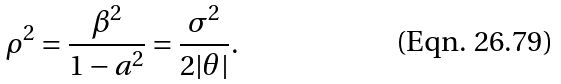Convert formula to latex. <formula><loc_0><loc_0><loc_500><loc_500>\rho ^ { 2 } = \frac { \beta ^ { 2 } } { 1 - a ^ { 2 } } = \frac { \sigma ^ { 2 } } { 2 | \theta | } .</formula> 